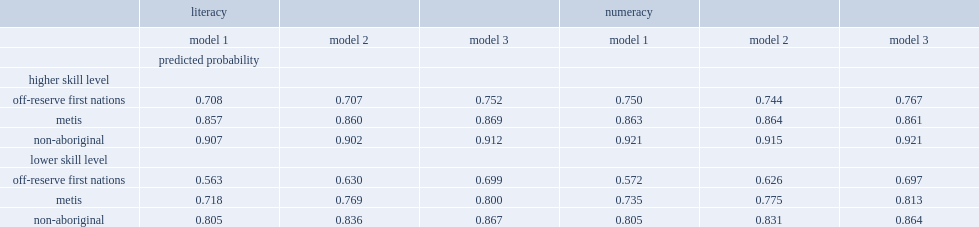Which kind of people has the highest probability of employment according to model 3 for literacy? Higher skill level non-aboriginal. What is probabilty of employment of the higher-skilled non-aboriginal population according to model 3 for literacy? 0.912. What is probabilty of employment of the higher-skilled metis population according to model 3 for literacy? 0.869. What is probabilty of employment of the higher-skilled first nations people living off reserve according to model 3 for literacy? 0.752. What is probabilty of employment of the lower-skilled non-aboriginal adults more than the higher-skilled off-reserve first nations population according to model 3 for literacy? 0.115. 